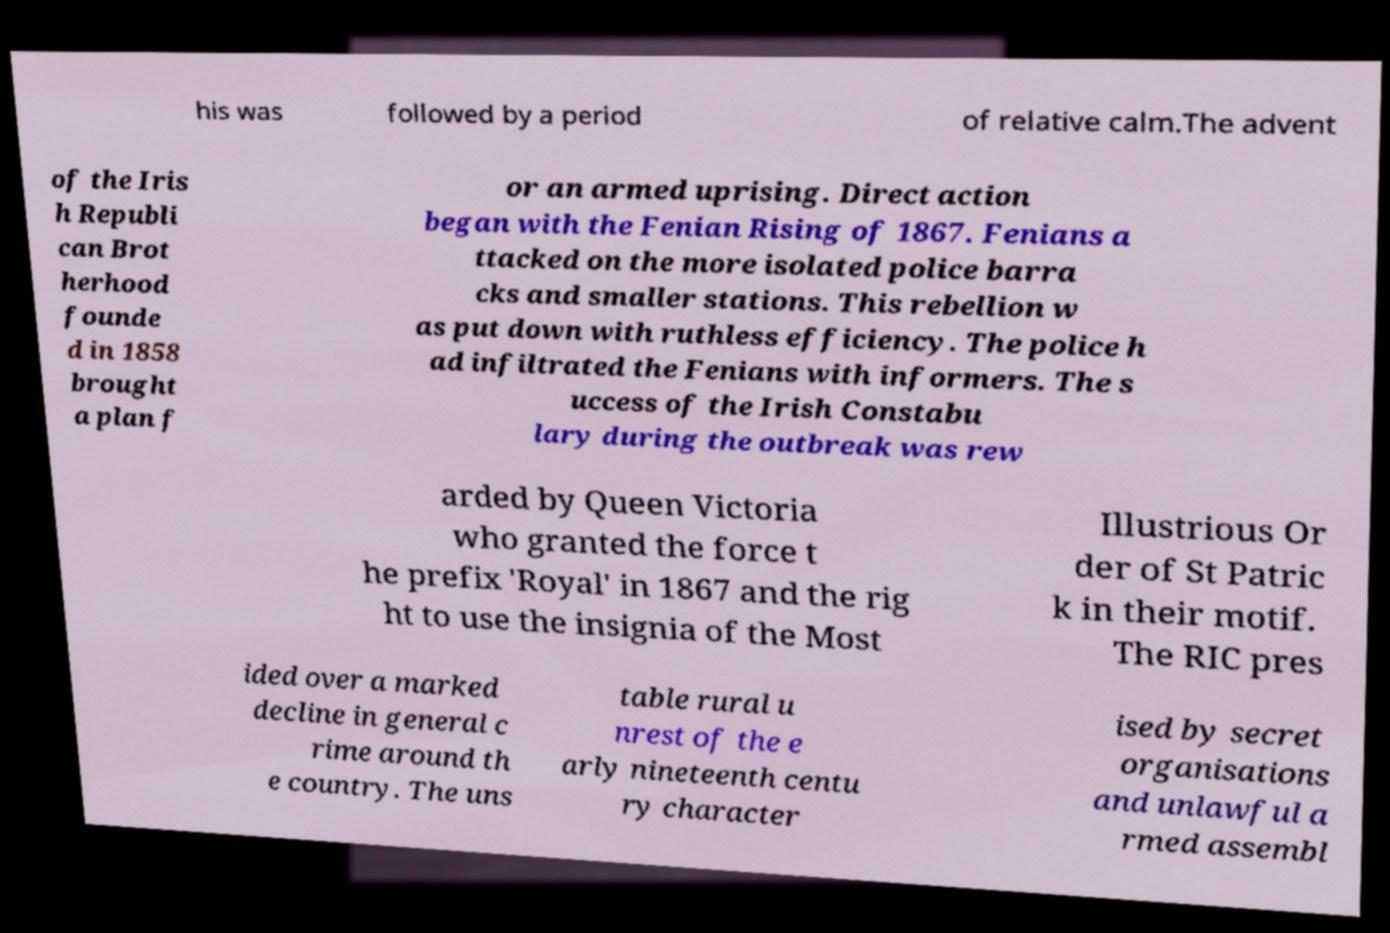Please read and relay the text visible in this image. What does it say? his was followed by a period of relative calm.The advent of the Iris h Republi can Brot herhood founde d in 1858 brought a plan f or an armed uprising. Direct action began with the Fenian Rising of 1867. Fenians a ttacked on the more isolated police barra cks and smaller stations. This rebellion w as put down with ruthless efficiency. The police h ad infiltrated the Fenians with informers. The s uccess of the Irish Constabu lary during the outbreak was rew arded by Queen Victoria who granted the force t he prefix 'Royal' in 1867 and the rig ht to use the insignia of the Most Illustrious Or der of St Patric k in their motif. The RIC pres ided over a marked decline in general c rime around th e country. The uns table rural u nrest of the e arly nineteenth centu ry character ised by secret organisations and unlawful a rmed assembl 